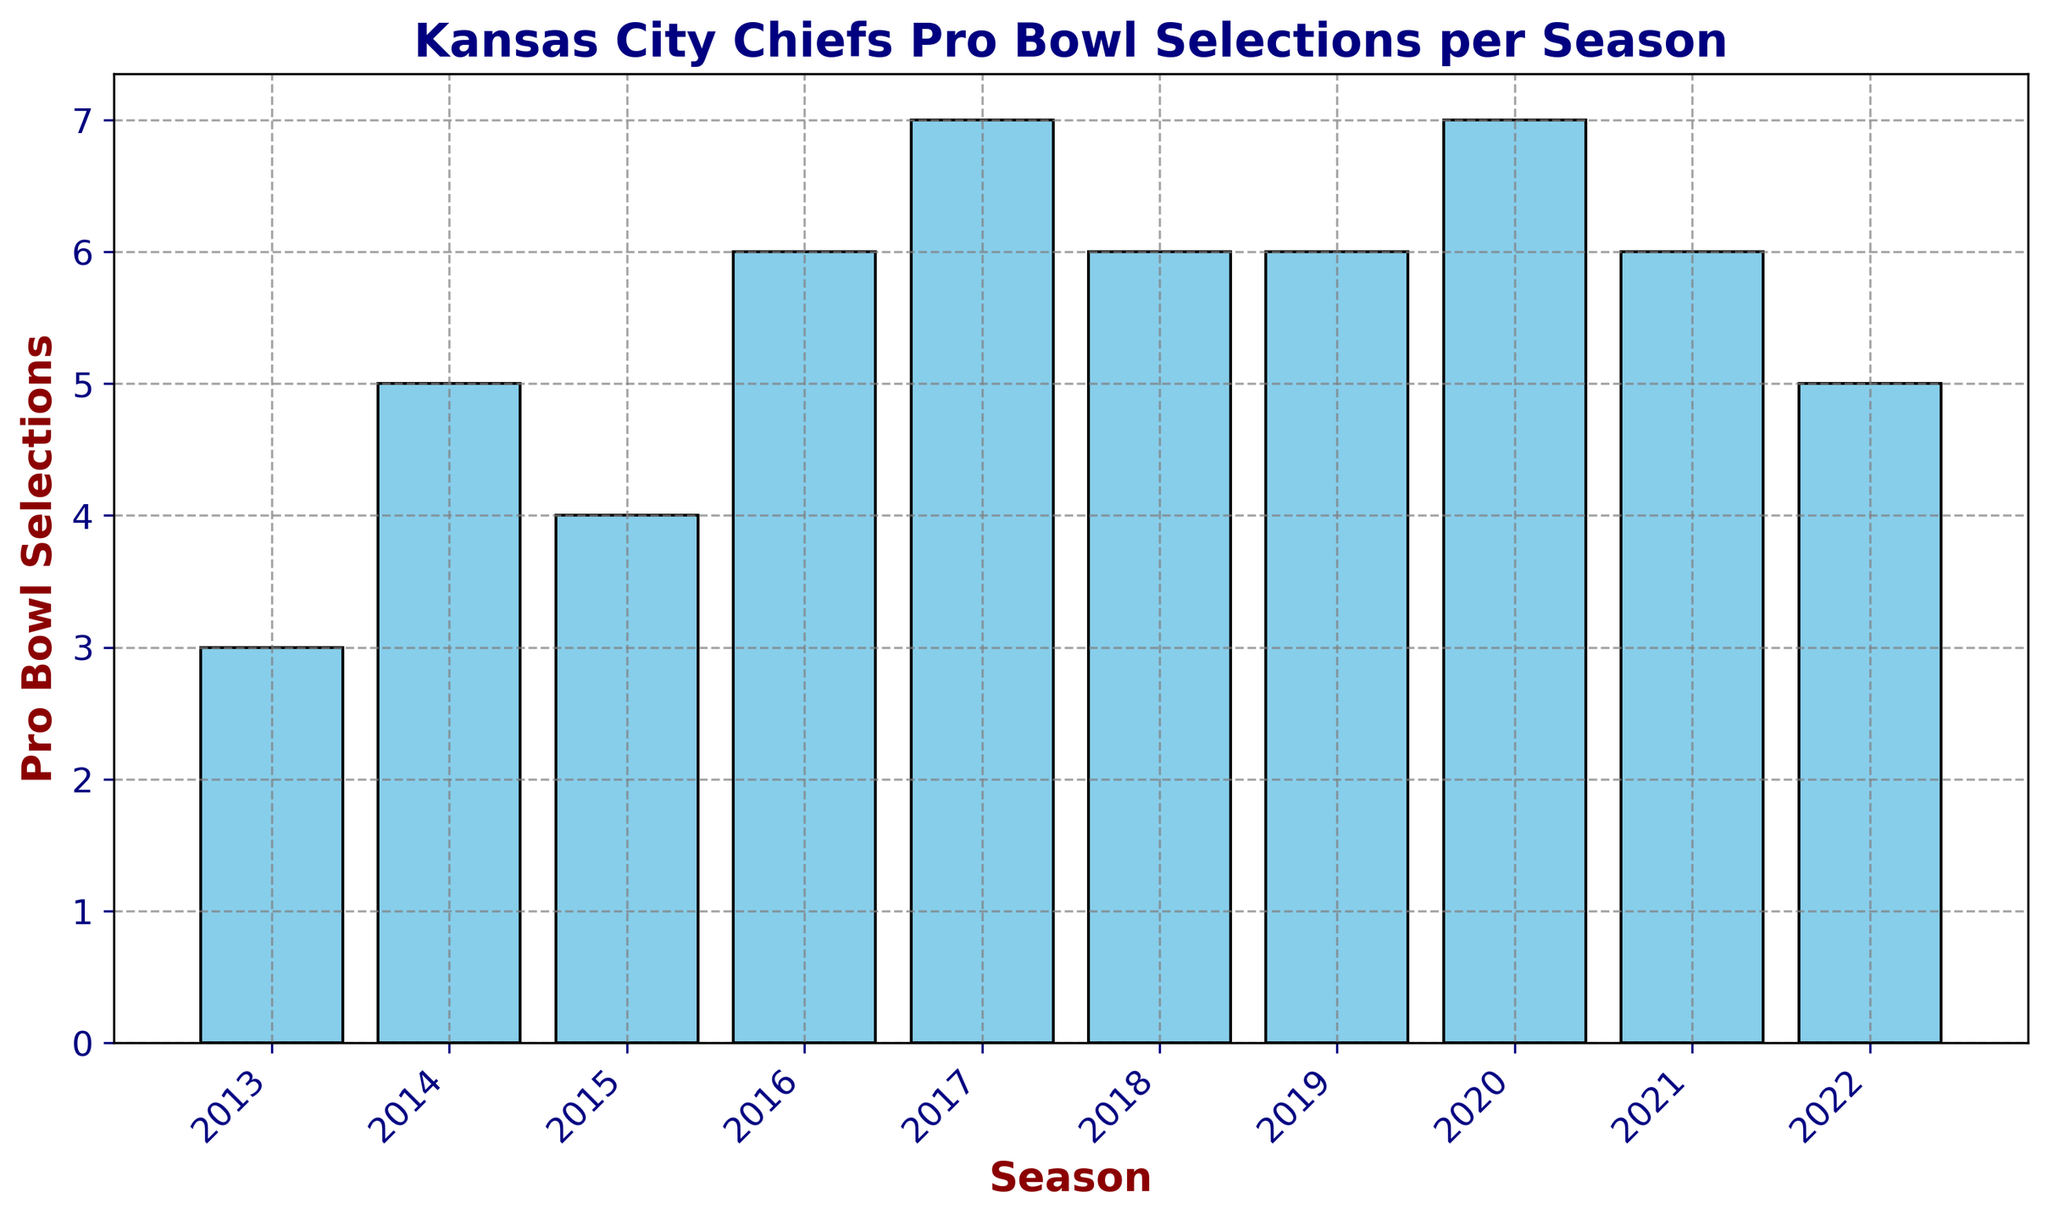What's the range of Pro Bowl selections over the seasons? To determine the range, subtract the minimum number of Pro Bowl selections from the maximum number. From the bar heights, the minimum is 3 (2013) and the maximum is 7 (2017 and 2020). So, the range is 7 - 3.
Answer: 4 In which seasons did the Kansas City Chiefs have the highest number of Pro Bowl selections? Look for the tallest bars in the figure, which correspond to the highest number of Pro Bowl selections. Both the 2017 and 2020 seasons have the highest bars, indicating 7 selections each.
Answer: 2017 and 2020 What is the total number of Pro Bowl selections from 2013 to 2022? Add up the heights of all the bars: 3 (2013) + 5 (2014) + 4 (2015) + 6 (2016) + 7 (2017) + 6 (2018) + 6 (2019) + 7 (2020) + 6 (2021) + 5 (2022) = 55.
Answer: 55 How did the number of Pro Bowl selections change from 2013 to 2014? Compare the heights of the bars for 2013 and 2014. The bar for 2013 is at 3 and for 2014 is at 5. So, the change is 5 - 3.
Answer: Increase by 2 Which season saw a drop in the number of Pro Bowl selections from the previous year? Look for a bar that is shorter than the previous one. The 2015 season has 4 selections, down from 5 in 2014.
Answer: 2015 What is the average number of Pro Bowl selections per season over this period? Add up the total number of selections (which is 55, as calculated previously) and divide by the number of seasons (10). So, the average is 55 / 10.
Answer: 5.5 Is there any season where the Pro Bowl selections remained constant as compared to the previous season? Look for pairs of consecutive bars with the same height. The 2018 and 2019 seasons both have bars at 6.
Answer: Yes, 2018 and 2019 How many seasons had more than 5 Pro Bowl selections? Count the number of bars that are taller than 5. These are for the 2016, 2017, 2018, 2019, 2020, and 2021 seasons.
Answer: 6 Which season had the lowest number of Pro Bowl selections, and what was that number? Identify the shortest bar in the figure. The shortest bar is for the 2013 season with 3 selections.
Answer: 2013, 3 